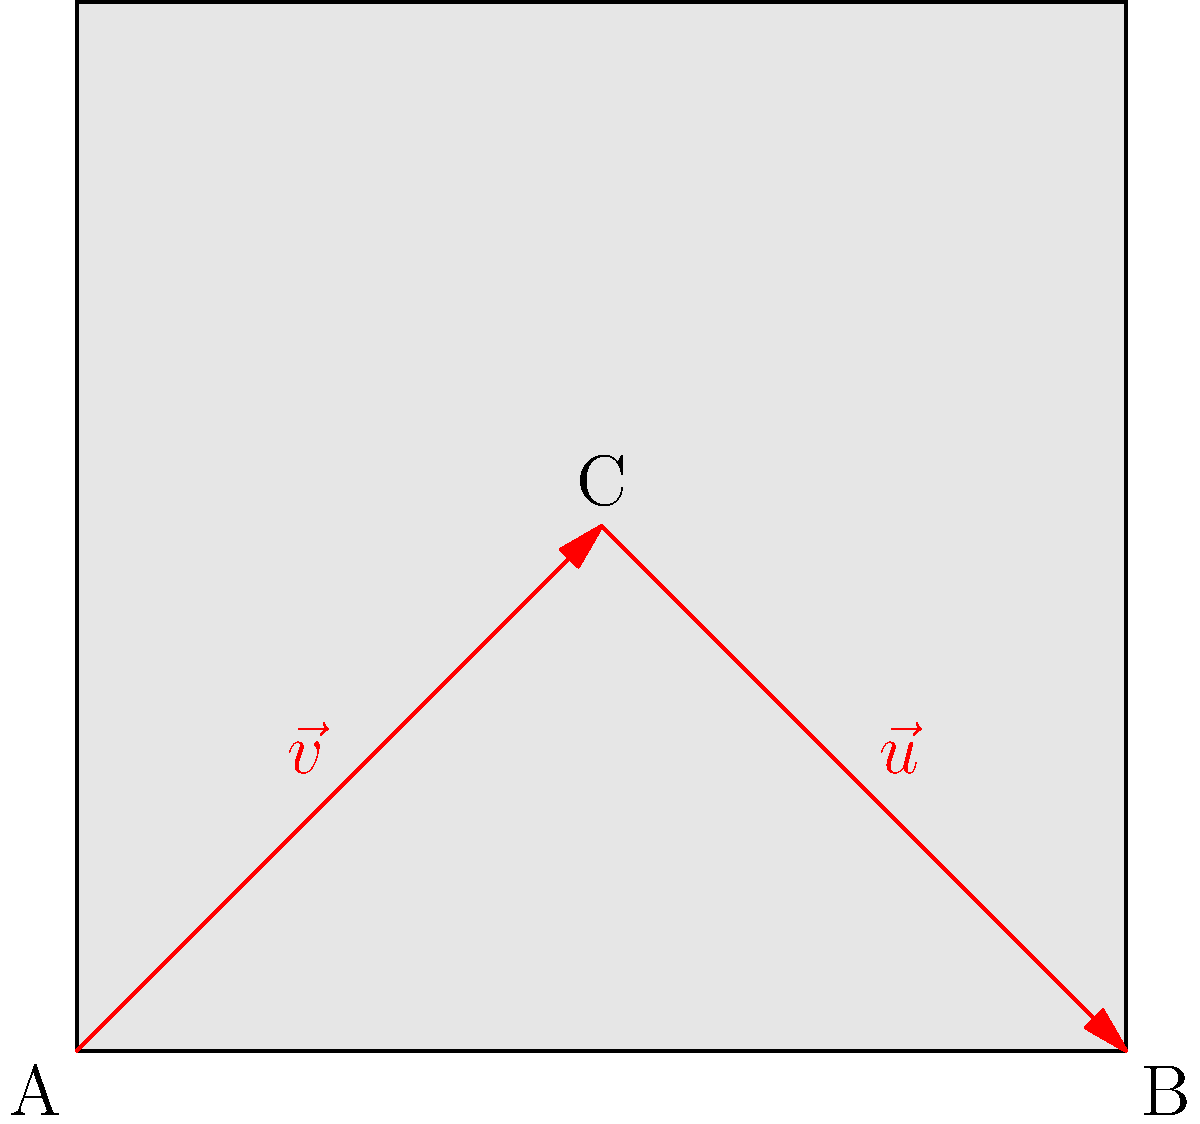In a traditional Kashmiri carpet design, a symmetrical pattern is formed by two vectors $\vec{v}$ and $\vec{u}$ as shown in the figure. Vector $\vec{v}$ starts from point A(0,0) and ends at point C(1,1), while vector $\vec{u}$ starts from C and ends at B(2,0). If we decompose vector $\vec{u}$ into its horizontal and vertical components, what is the magnitude of its vertical component? To solve this problem, we'll follow these steps:

1) First, we need to find the components of vector $\vec{u}$:
   
   $\vec{u} = \overrightarrow{CB} = (2,0) - (1,1) = (1,-1)$

2) Now we have $\vec{u}$ in component form: $\vec{u} = (1,-1)$

3) The vertical component of $\vec{u}$ is the y-component, which is -1.

4) The magnitude of a vector component is its absolute value.

5) Therefore, the magnitude of the vertical component of $\vec{u}$ is |-1| = 1.

This result shows that the vertical component of $\vec{u}$ has a magnitude of 1 unit, which contributes to the symmetry of the pattern in the Kashmiri carpet design.
Answer: 1 